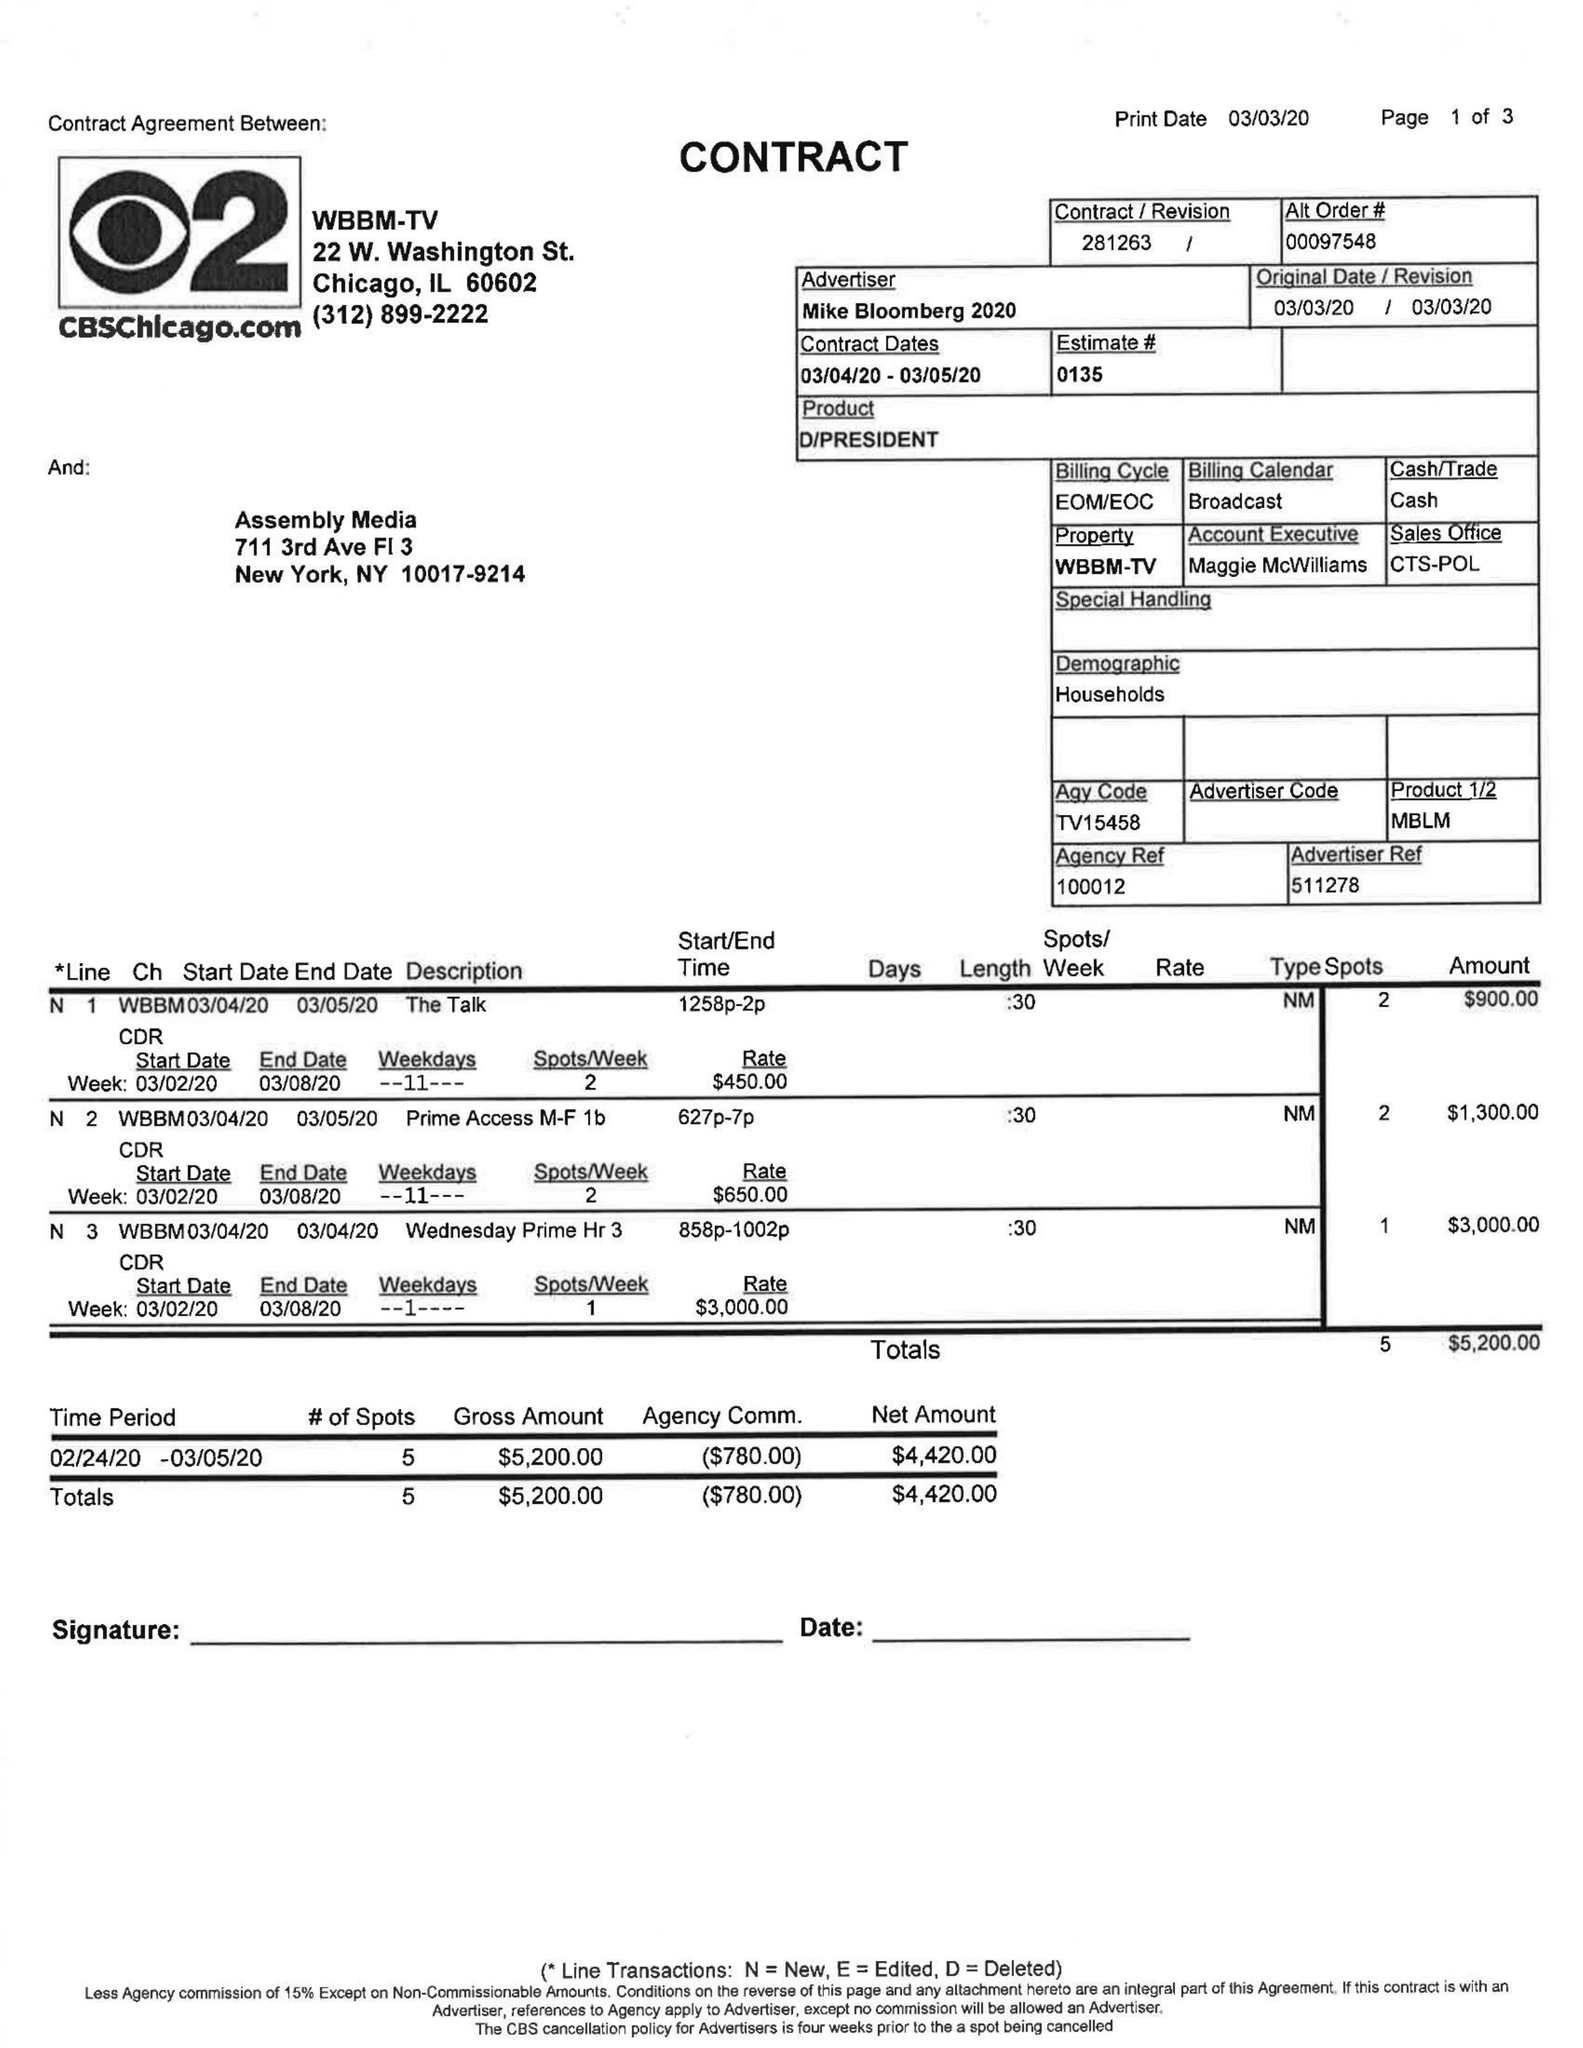What is the value for the contract_num?
Answer the question using a single word or phrase. 281263 